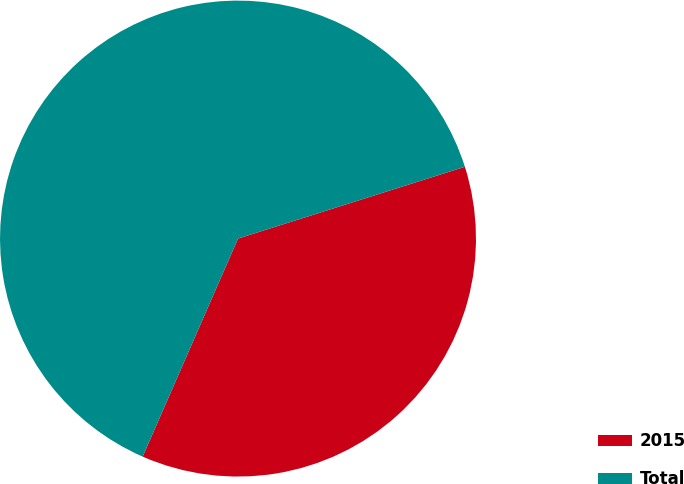<chart> <loc_0><loc_0><loc_500><loc_500><pie_chart><fcel>2015<fcel>Total<nl><fcel>36.44%<fcel>63.56%<nl></chart> 